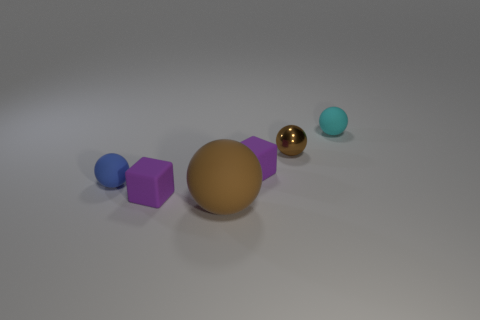Subtract 1 spheres. How many spheres are left? 3 Subtract all spheres. How many objects are left? 2 Add 3 brown spheres. How many objects exist? 9 Subtract all large cyan matte things. Subtract all small brown things. How many objects are left? 5 Add 3 brown balls. How many brown balls are left? 5 Add 2 small purple matte blocks. How many small purple matte blocks exist? 4 Subtract 0 yellow cylinders. How many objects are left? 6 